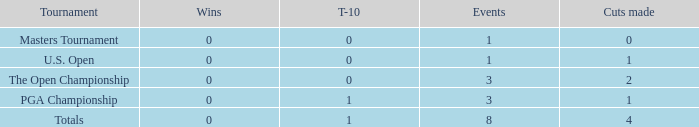For events with values of exactly 1, and 0 cuts made, what is the fewest number of top-10s? 0.0. 